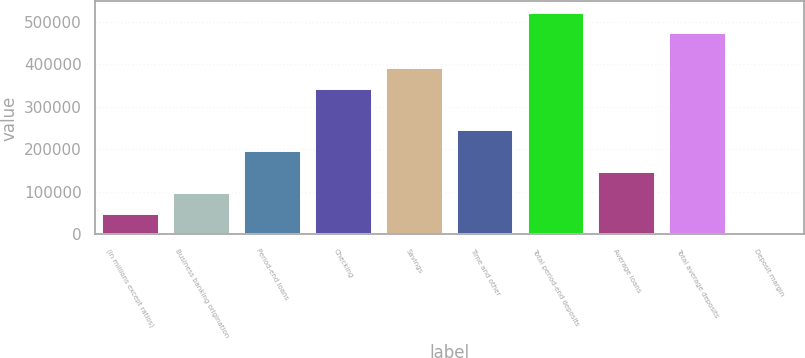Convert chart to OTSL. <chart><loc_0><loc_0><loc_500><loc_500><bar_chart><fcel>(in millions except ratios)<fcel>Business banking origination<fcel>Period-end loans<fcel>Checking<fcel>Savings<fcel>Time and other<fcel>Total period-end deposits<fcel>Average loans<fcel>Total average deposits<fcel>Deposit margin<nl><fcel>48956.6<fcel>97911<fcel>195820<fcel>342683<fcel>391637<fcel>244774<fcel>521288<fcel>146865<fcel>472334<fcel>2.21<nl></chart> 